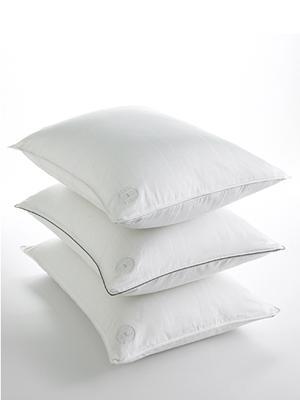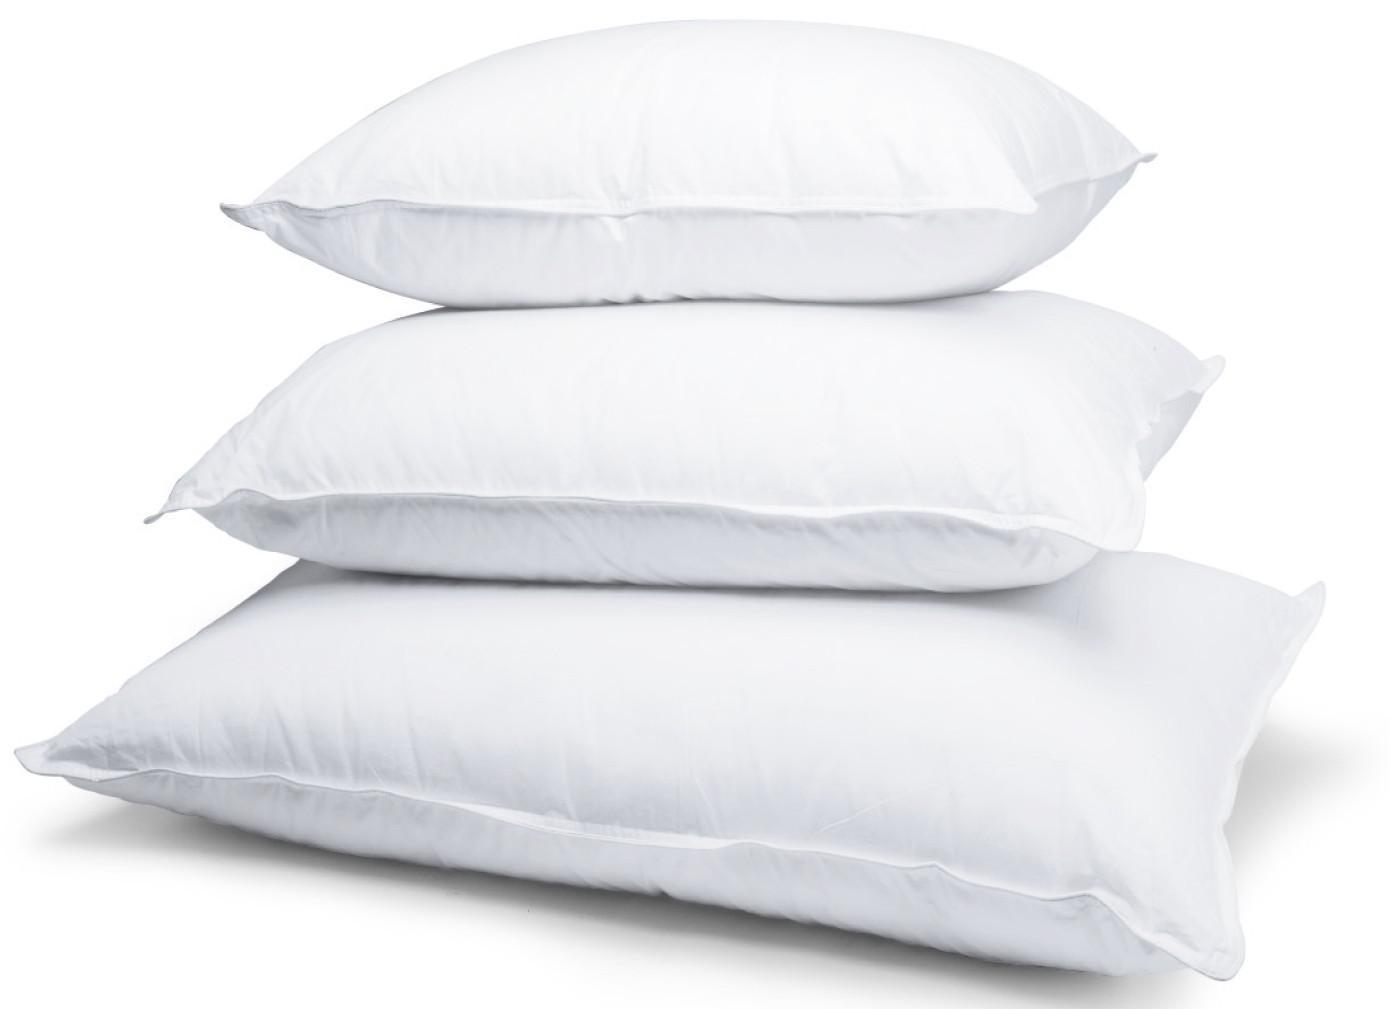The first image is the image on the left, the second image is the image on the right. For the images shown, is this caption "Left and right images each contain exactly three white pillows arranged in a vertical stack." true? Answer yes or no. Yes. The first image is the image on the left, the second image is the image on the right. Evaluate the accuracy of this statement regarding the images: "There are two stacks of three pillows.". Is it true? Answer yes or no. Yes. 